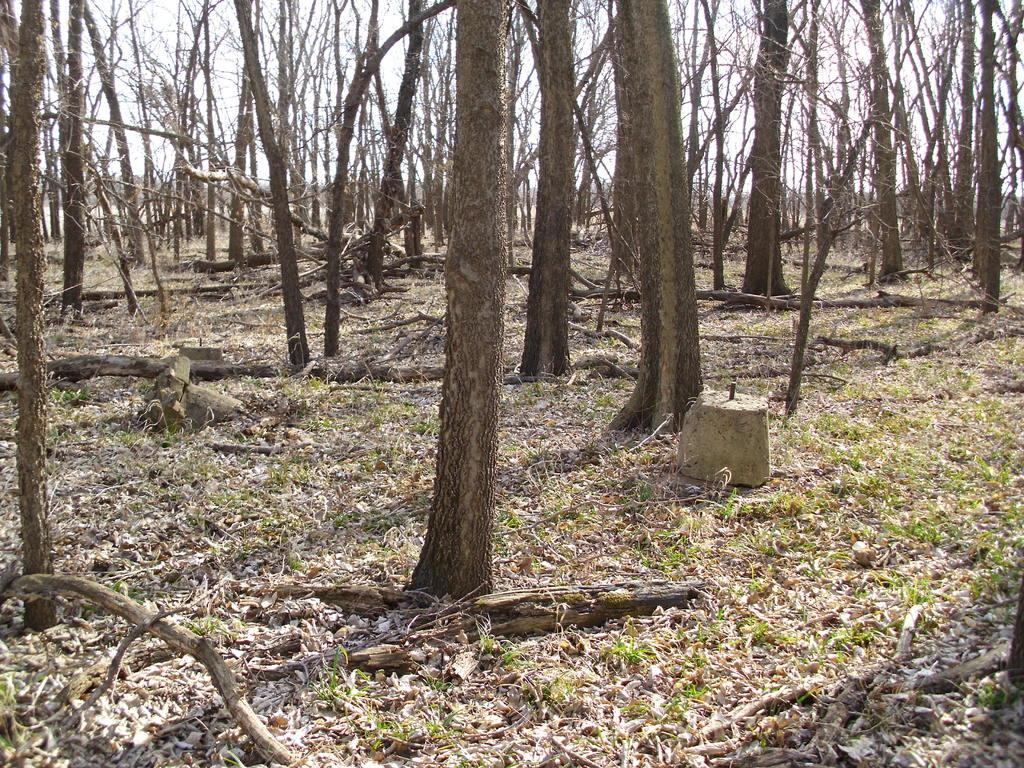What type of environment is shown in the image? The image depicts a view of a forest. What is the condition of the trees in the front of the image? The trees in the front of the image are dry. What can be seen on the ground in the image? Dry leaves are present on the ground in the image. Where is the stove located in the image? There is no stove present in the image; it is a view of a forest with dry trees and leaves. Can you see a trail in the image? The image does not show a trail; it is a view of a forest with dry trees and leaves. 